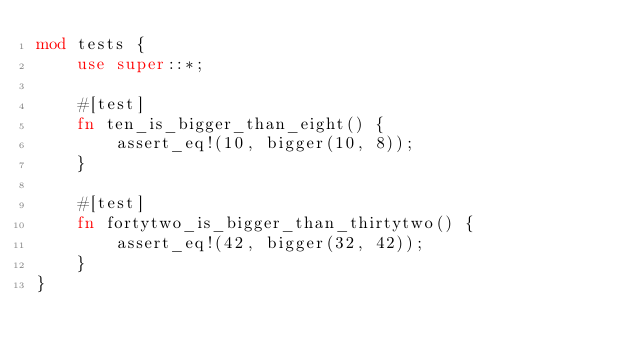<code> <loc_0><loc_0><loc_500><loc_500><_Rust_>mod tests {
    use super::*;

    #[test]
    fn ten_is_bigger_than_eight() {
        assert_eq!(10, bigger(10, 8));
    }

    #[test]
    fn fortytwo_is_bigger_than_thirtytwo() {
        assert_eq!(42, bigger(32, 42));
    }
}
</code> 